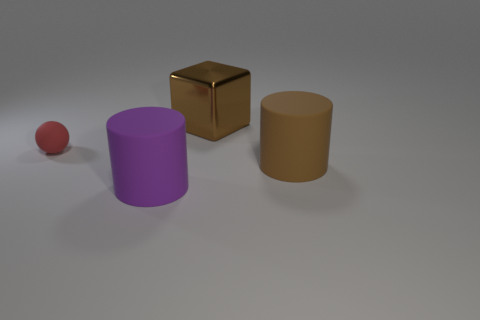Are there any other things that have the same size as the red rubber object?
Your response must be concise. No. What number of other things are the same color as the rubber ball?
Make the answer very short. 0. How many spheres are either small purple matte things or small red objects?
Your answer should be compact. 1. The small matte sphere that is on the left side of the brown object in front of the red ball is what color?
Your response must be concise. Red. The brown rubber object has what shape?
Provide a short and direct response. Cylinder. Is the size of the brown object behind the rubber sphere the same as the purple matte cylinder?
Offer a very short reply. Yes. Are there any big things that have the same material as the tiny thing?
Provide a succinct answer. Yes. How many things are big objects that are to the right of the large purple object or brown rubber cylinders?
Keep it short and to the point. 2. Is there a small gray shiny cylinder?
Your answer should be compact. No. There is a rubber thing that is both right of the red rubber ball and behind the purple rubber cylinder; what shape is it?
Ensure brevity in your answer.  Cylinder. 